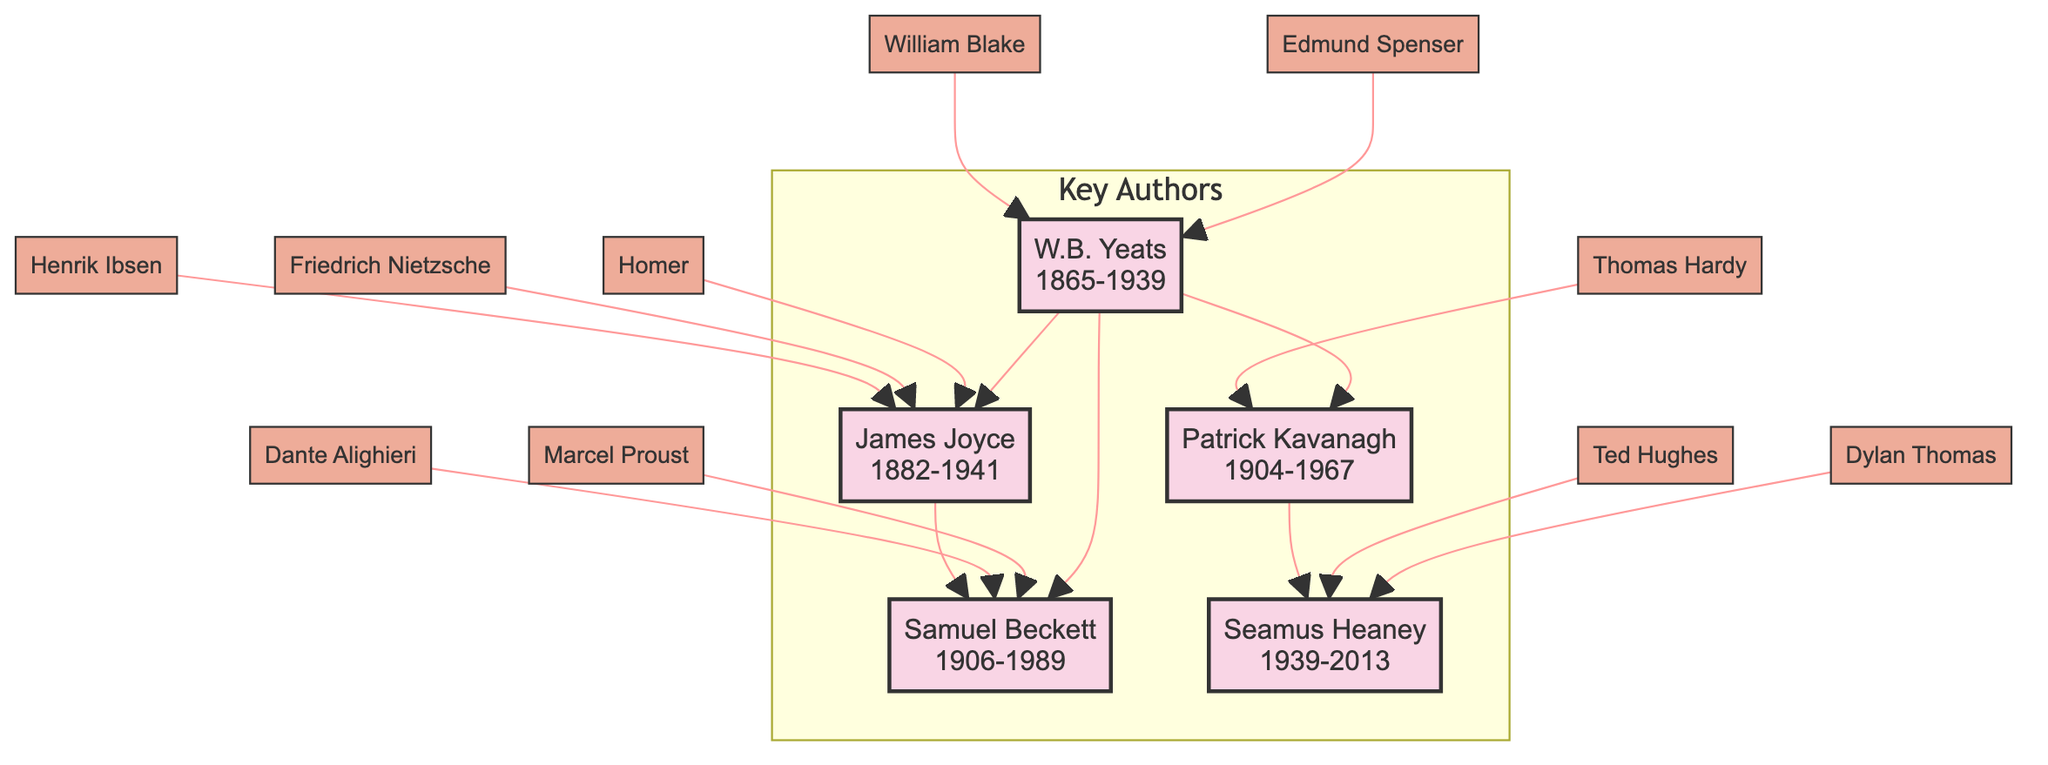What years did James Joyce live? James Joyce was born in 1882 and died in 1941. This information is found directly on his node.
Answer: 1882-1941 Who influenced Samuel Beckett? The influences on Samuel Beckett, as listed on his node, include James Joyce, Dante Alighieri, and Marcel Proust. This is gathered from the arrows pointing to his node.
Answer: James Joyce, Dante Alighieri, Marcel Proust How many notable works did Seamus Heaney have? Seamus Heaney's node lists three notable works: "Death of a Naturalist", "North", and "Field Work". This can be counted directly from the listing.
Answer: 3 Which author influenced Patrick Kavanagh? The node for Patrick Kavanagh shows that he was influenced by Thomas Hardy and W.B. Yeats. This information is found within the influence connections on his node.
Answer: Thomas Hardy, W.B. Yeats Who is directly influenced by Patrick Kavanagh? According to the node of Patrick Kavanagh, he influenced Seamus Heaney, which is shown by an arrow pointing from Kavanagh to Heaney.
Answer: Seamus Heaney Which two authors are influenced by W.B. Yeats? W.B. Yeats influenced two authors: James Joyce and Samuel Beckett, as shown by the arrows leading from Yeats to these two nodes.
Answer: James Joyce, Samuel Beckett What is the relationship between James Joyce and Samuel Beckett? James Joyce is the direct influence on Samuel Beckett, indicated by an arrow pointing from Joyce to Beckett. This means Joyce had an impact on Beckett's literary work.
Answer: Influencer What notable works did W.B. Yeats create? W.B. Yeats' node specifies his notable works: "The Tower", "The Winding Stair", and "The Rose". This can be directly listed from the information provided on his node.
Answer: The Tower, The Winding Stair, The Rose How many authors did James Joyce influence? James Joyce influenced two authors: Samuel Beckett and W.B. Yeats, as indicated by the lines pointing to their respective nodes. Therefore, if you count these connections, you conclude the total.
Answer: 2 